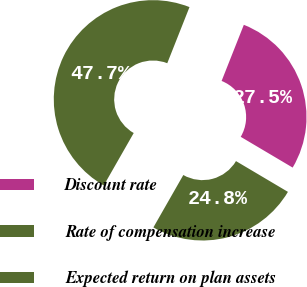<chart> <loc_0><loc_0><loc_500><loc_500><pie_chart><fcel>Discount rate<fcel>Rate of compensation increase<fcel>Expected return on plan assets<nl><fcel>27.51%<fcel>24.75%<fcel>47.74%<nl></chart> 